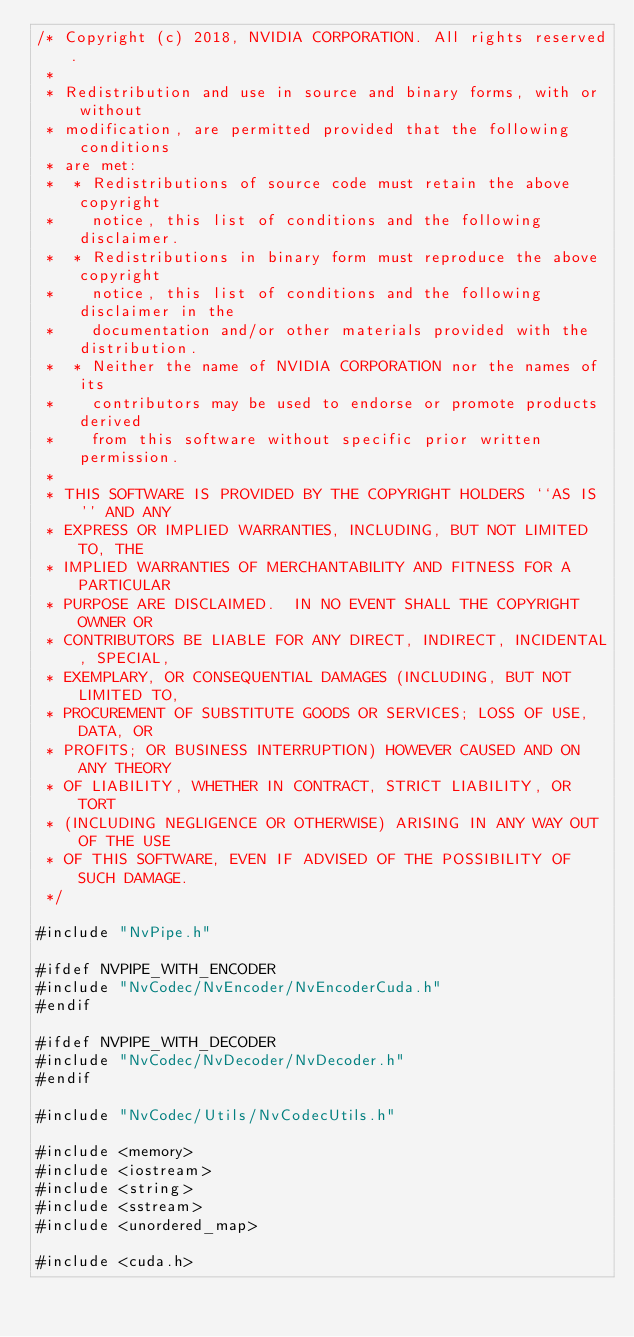<code> <loc_0><loc_0><loc_500><loc_500><_Cuda_>/* Copyright (c) 2018, NVIDIA CORPORATION. All rights reserved.
 *
 * Redistribution and use in source and binary forms, with or without
 * modification, are permitted provided that the following conditions
 * are met:
 *  * Redistributions of source code must retain the above copyright
 *    notice, this list of conditions and the following disclaimer.
 *  * Redistributions in binary form must reproduce the above copyright
 *    notice, this list of conditions and the following disclaimer in the
 *    documentation and/or other materials provided with the distribution.
 *  * Neither the name of NVIDIA CORPORATION nor the names of its
 *    contributors may be used to endorse or promote products derived
 *    from this software without specific prior written permission.
 *
 * THIS SOFTWARE IS PROVIDED BY THE COPYRIGHT HOLDERS ``AS IS'' AND ANY
 * EXPRESS OR IMPLIED WARRANTIES, INCLUDING, BUT NOT LIMITED TO, THE
 * IMPLIED WARRANTIES OF MERCHANTABILITY AND FITNESS FOR A PARTICULAR
 * PURPOSE ARE DISCLAIMED.  IN NO EVENT SHALL THE COPYRIGHT OWNER OR
 * CONTRIBUTORS BE LIABLE FOR ANY DIRECT, INDIRECT, INCIDENTAL, SPECIAL,
 * EXEMPLARY, OR CONSEQUENTIAL DAMAGES (INCLUDING, BUT NOT LIMITED TO,
 * PROCUREMENT OF SUBSTITUTE GOODS OR SERVICES; LOSS OF USE, DATA, OR
 * PROFITS; OR BUSINESS INTERRUPTION) HOWEVER CAUSED AND ON ANY THEORY
 * OF LIABILITY, WHETHER IN CONTRACT, STRICT LIABILITY, OR TORT
 * (INCLUDING NEGLIGENCE OR OTHERWISE) ARISING IN ANY WAY OUT OF THE USE
 * OF THIS SOFTWARE, EVEN IF ADVISED OF THE POSSIBILITY OF SUCH DAMAGE.
 */

#include "NvPipe.h"

#ifdef NVPIPE_WITH_ENCODER
#include "NvCodec/NvEncoder/NvEncoderCuda.h"
#endif

#ifdef NVPIPE_WITH_DECODER
#include "NvCodec/NvDecoder/NvDecoder.h"
#endif

#include "NvCodec/Utils/NvCodecUtils.h"

#include <memory>
#include <iostream>
#include <string>
#include <sstream>
#include <unordered_map>

#include <cuda.h></code> 